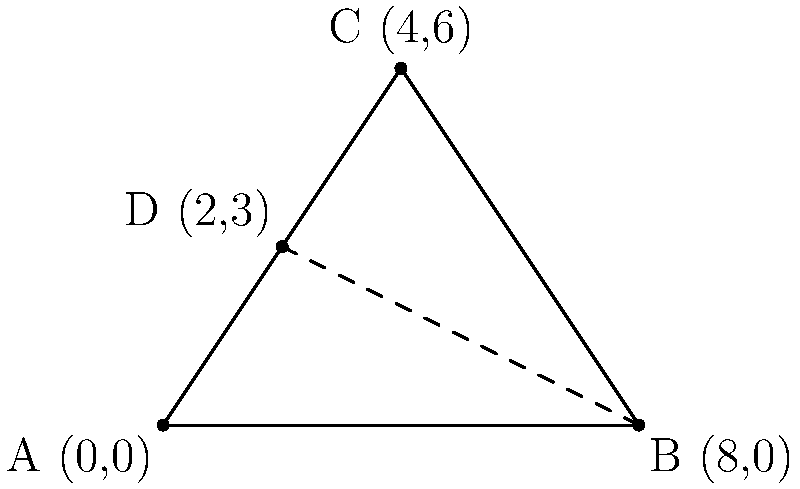Three existing mental health facilities are located at coordinates A(0,0), B(8,0), and C(4,6) in a city. A new facility is proposed at point D(2,3). To optimize accessibility, the new facility should be placed at the point that minimizes the sum of distances to all existing facilities. Is point D the optimal location for the new facility? If not, determine the coordinates of the optimal location. To determine if point D is the optimal location, we need to follow these steps:

1. Calculate the sum of distances from D to A, B, and C.
2. Find the optimal location using the geometric median (Fermat point) of triangle ABC.
3. Compare the results.

Step 1: Calculating distances from D to A, B, and C
- DA = $\sqrt{(2-0)^2 + (3-0)^2} = \sqrt{13}$
- DB = $\sqrt{(2-8)^2 + (3-0)^2} = \sqrt{45}$
- DC = $\sqrt{(2-4)^2 + (3-6)^2} = \sqrt{13}$

Sum of distances = $\sqrt{13} + \sqrt{45} + \sqrt{13} \approx 13.86$

Step 2: Finding the optimal location (Fermat point)
For a triangle with all angles less than 120°, the Fermat point is located where the three lines connecting each vertex to the opposite side's Fermat point intersect. The coordinates of the Fermat point can be approximated as:

$x = \frac{x_A + x_B + x_C}{3} = \frac{0 + 8 + 4}{3} = 4$
$y = \frac{y_A + y_B + y_C}{3} = \frac{0 + 0 + 6}{3} = 2$

So, the optimal location is approximately (4,2).

Step 3: Comparing results
The sum of distances from (4,2) to A, B, and C:
- $\sqrt{4^2 + 2^2} = \sqrt{20}$
- $\sqrt{4^2 + 2^2} = \sqrt{20}$
- $\sqrt{0^2 + 4^2} = 4$

Sum of distances = $2\sqrt{20} + 4 \approx 12.94$

Since 12.94 < 13.86, the point (4,2) is a better location than D(2,3).
Answer: No, (4,2) is the optimal location. 